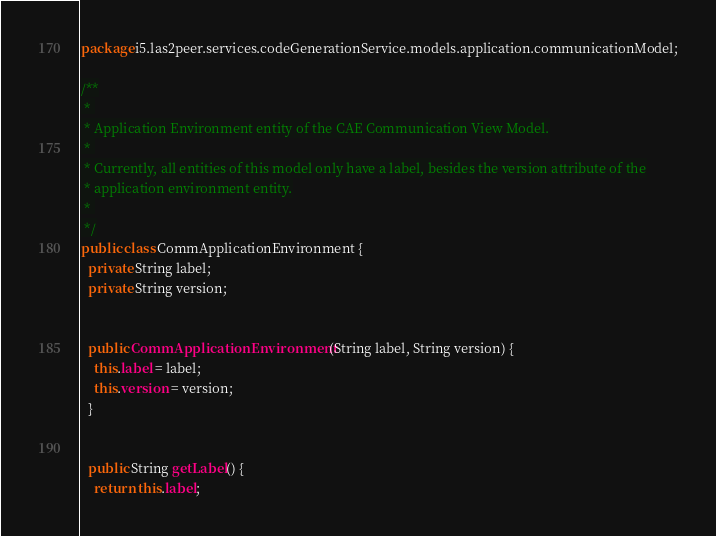Convert code to text. <code><loc_0><loc_0><loc_500><loc_500><_Java_>package i5.las2peer.services.codeGenerationService.models.application.communicationModel;

/**
 * 
 * Application Environment entity of the CAE Communication View Model.
 * 
 * Currently, all entities of this model only have a label, besides the version attribute of the
 * application environment entity.
 * 
 */
public class CommApplicationEnvironment {
  private String label;
  private String version;


  public CommApplicationEnvironment(String label, String version) {
    this.label = label;
    this.version = version;
  }


  public String getLabel() {
    return this.label;</code> 